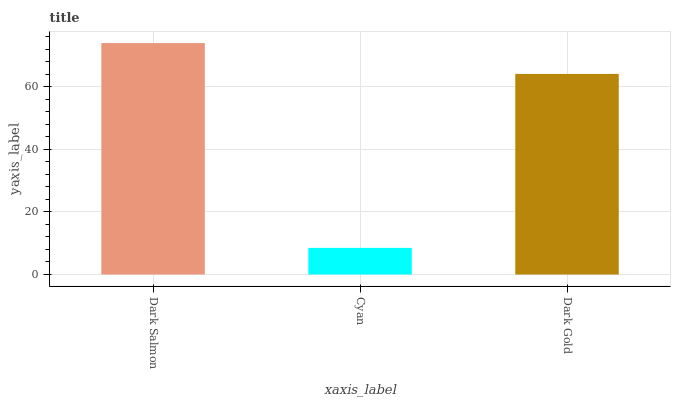Is Cyan the minimum?
Answer yes or no. Yes. Is Dark Salmon the maximum?
Answer yes or no. Yes. Is Dark Gold the minimum?
Answer yes or no. No. Is Dark Gold the maximum?
Answer yes or no. No. Is Dark Gold greater than Cyan?
Answer yes or no. Yes. Is Cyan less than Dark Gold?
Answer yes or no. Yes. Is Cyan greater than Dark Gold?
Answer yes or no. No. Is Dark Gold less than Cyan?
Answer yes or no. No. Is Dark Gold the high median?
Answer yes or no. Yes. Is Dark Gold the low median?
Answer yes or no. Yes. Is Cyan the high median?
Answer yes or no. No. Is Dark Salmon the low median?
Answer yes or no. No. 